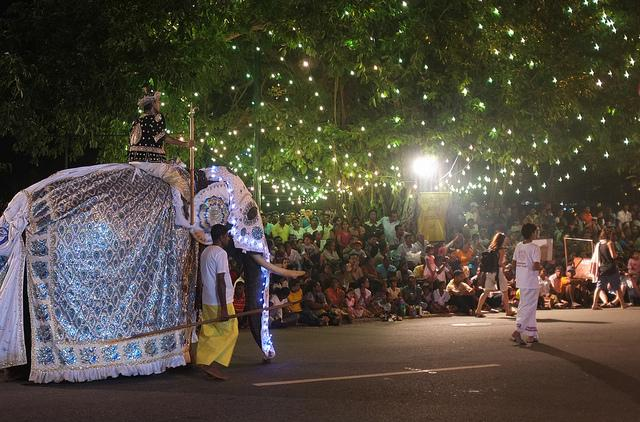Which part of the animal is precious? tusk 